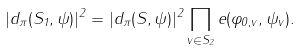<formula> <loc_0><loc_0><loc_500><loc_500>| d _ { \pi } ( S _ { 1 } , \psi ) | ^ { 2 } = | d _ { \pi } ( S , \psi ) | ^ { 2 } \prod _ { v \in S _ { 2 } } e ( \varphi _ { 0 , v } , \psi _ { v } ) .</formula> 